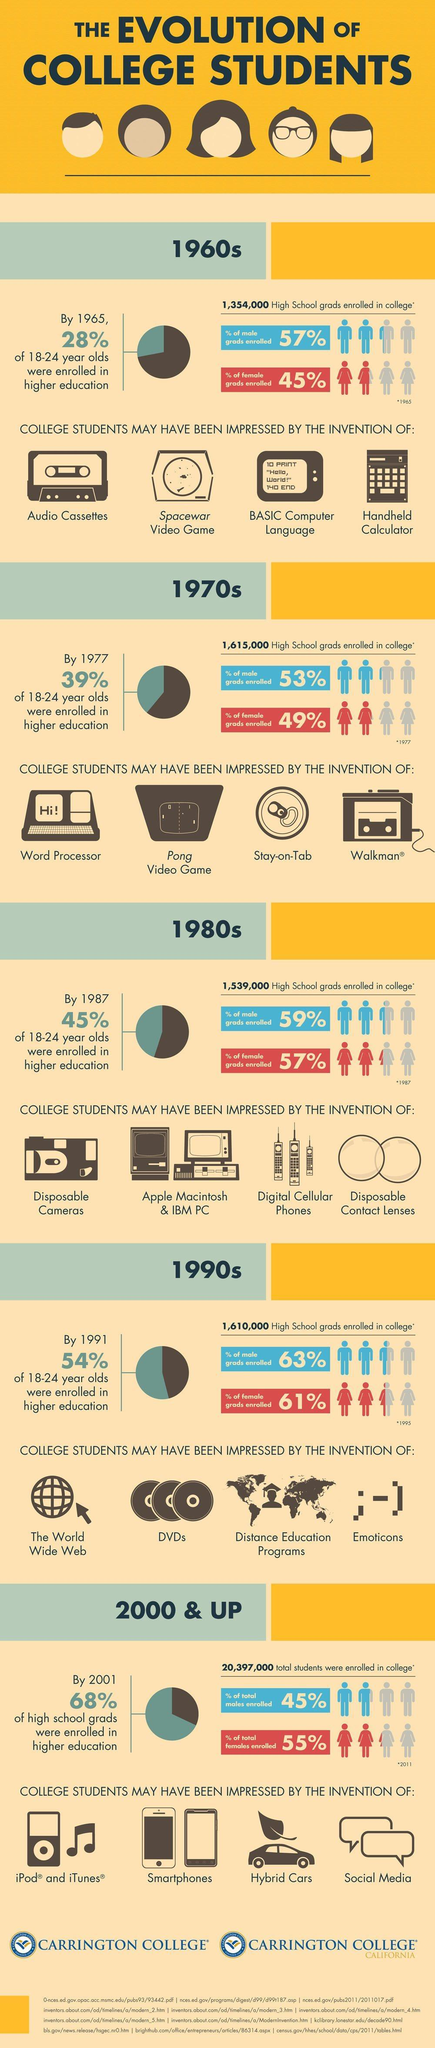What was the video game of the 1960s?
Answer the question with a short phrase. Spacewar In which decade was the contact lens invented? 1980s What type of cameras were invented in the 1980s? Disposable cameras What percent of 18 to 24 year olds did not enroll for higher education in 1987? 55% In which decade, was the percentage of males enrolled in colleges the highest? 1990s What was used to play music in the 1960s? Audio cassettes By what percentage was the male grads enrolled, higher than the female grads, in the 1980s? 2% For each decade, how many inventions a shown? 4 What type of phones were used in the 2000s? Smartphones What was the programming language of the 1960s? BASIC In which decade was the personal computer invented? 1980s In which decade was the digital cellular phone invented? 1980s What was the 'number' of male grads enrolled in colleges in the 1960s? 7,71,780 Which decade shows a decrease in the number of High School grads enrolled in colleges? 1980s In which decade was the percentage of females enrolled in colleges, higher than that of males? 2000 & up In which decade was the Walkman invented? 1970s What are the first three inventions that impressed the college students, in the 1990s? The world wide web, DVDs, Distance education programs What was the video game of the 1970s? Pong 